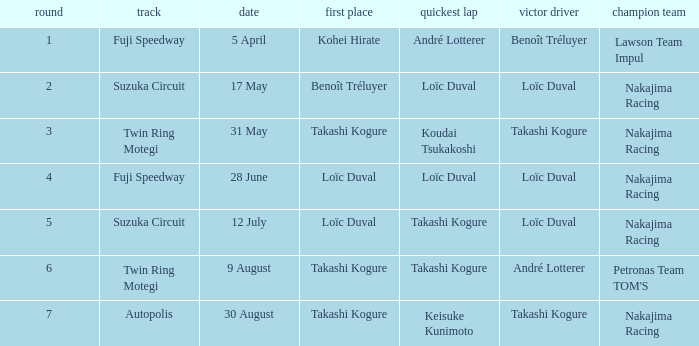How many drivers drove on Suzuka Circuit where Loïc Duval took pole position? 1.0. 